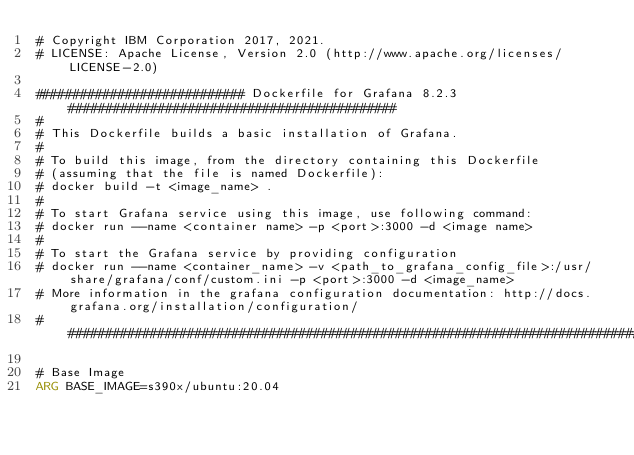Convert code to text. <code><loc_0><loc_0><loc_500><loc_500><_Dockerfile_># Copyright IBM Corporation 2017, 2021.
# LICENSE: Apache License, Version 2.0 (http://www.apache.org/licenses/LICENSE-2.0)

############################ Dockerfile for Grafana 8.2.3 ############################################
#
# This Dockerfile builds a basic installation of Grafana.
#
# To build this image, from the directory containing this Dockerfile
# (assuming that the file is named Dockerfile):
# docker build -t <image_name> .
#
# To start Grafana service using this image, use following command:
# docker run --name <container name> -p <port>:3000 -d <image name>
#
# To start the Grafana service by providing configuration
# docker run --name <container_name> -v <path_to_grafana_config_file>:/usr/share/grafana/conf/custom.ini -p <port>:3000 -d <image_name>
# More information in the grafana configuration documentation: http://docs.grafana.org/installation/configuration/
################################################################################################################

# Base Image
ARG BASE_IMAGE=s390x/ubuntu:20.04</code> 